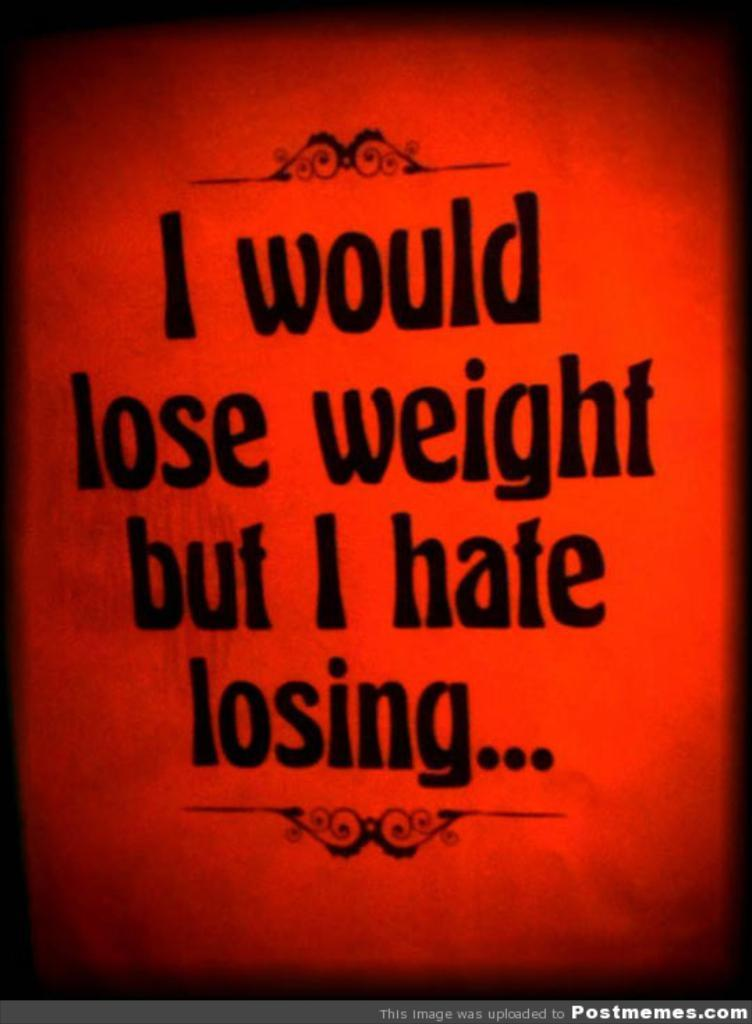<image>
Create a compact narrative representing the image presented. A red poster that says I would lose weight but I hate losing. 